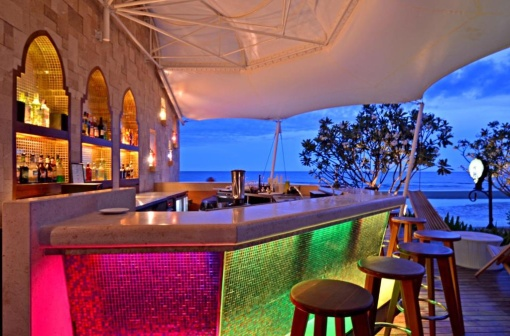Write a detailed description of the given image. The image captures an inviting scene at a beachside bar, perfect for a relaxing evening. The bar is constructed from stone and is illuminated with vibrant, colorful lights; a soft pink and green glow emanates from the backlit mosaic tiles. A white, elegantly draped canopy provides shade, giving the setting a tranquil and shaded ambiance. Three unoccupied bar stools are strategically placed in front of the bar as though waiting for patrons to take a seat and enjoy the breathtaking view. To the right of the bar, a lush tree, its leaves swaying gently in the sea breeze, adds a touch of nature. The serene ocean extends to the horizon in the background, its calm waters mirroring the sky's hues of blue and amber. Adding an artistic flair to the scene, a white bird sculpture stands to the right. This composition harmoniously blends the allure of artificial lighting and architectural beauty with the calming presence of natural elements. 